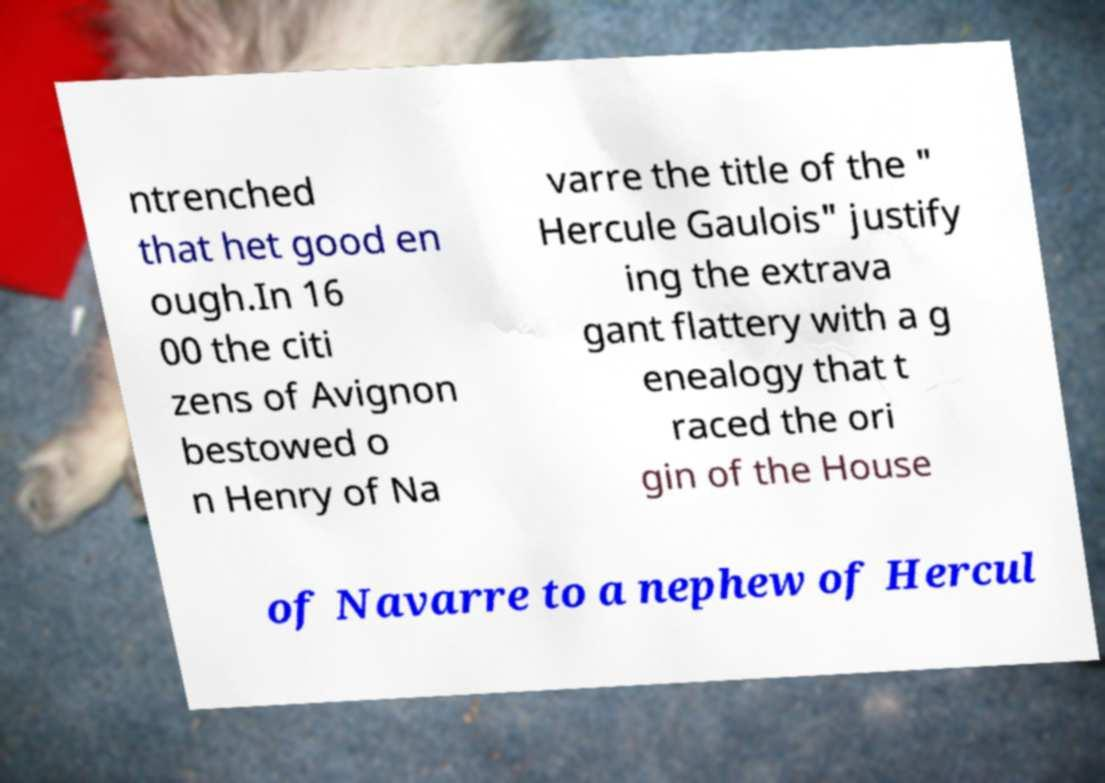For documentation purposes, I need the text within this image transcribed. Could you provide that? ntrenched that het good en ough.In 16 00 the citi zens of Avignon bestowed o n Henry of Na varre the title of the " Hercule Gaulois" justify ing the extrava gant flattery with a g enealogy that t raced the ori gin of the House of Navarre to a nephew of Hercul 